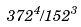Convert formula to latex. <formula><loc_0><loc_0><loc_500><loc_500>3 7 2 ^ { 4 } / 1 5 2 ^ { 3 }</formula> 